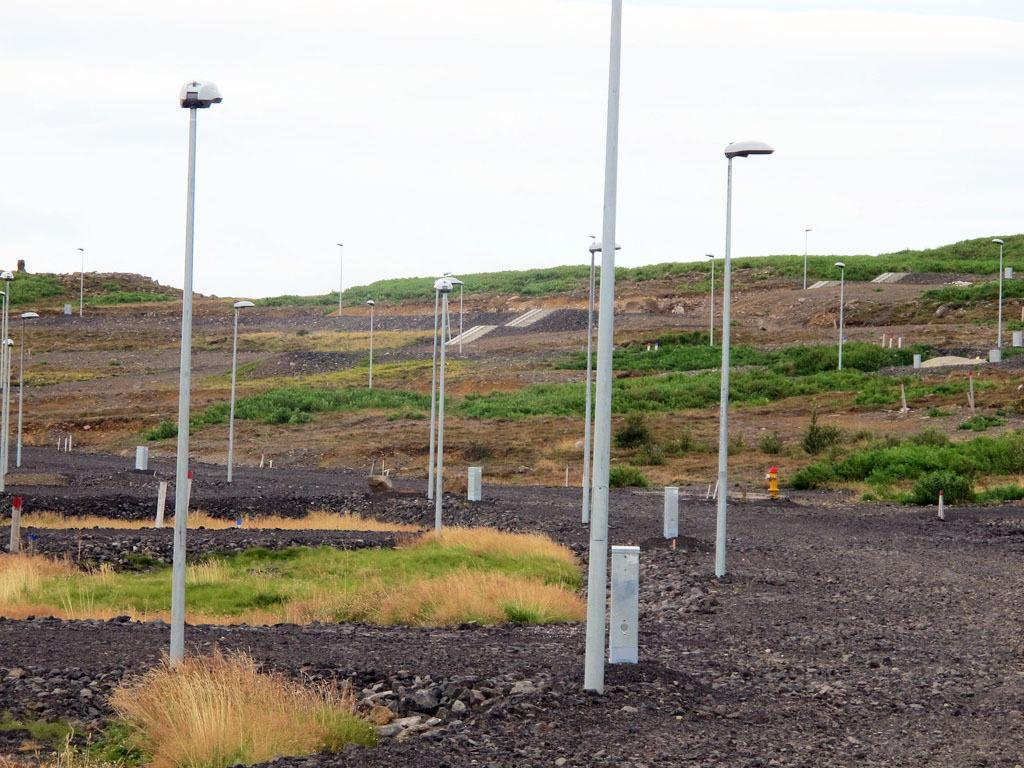What structures are present in the image? There are poles in the image. What else can be seen in the image besides the poles? There are lights and plants in the image. What type of stove is visible in the image? There is no stove present in the image. How does the mother interact with the plants in the image? There is no mother present in the image, and therefore no interaction with the plants can be observed. 